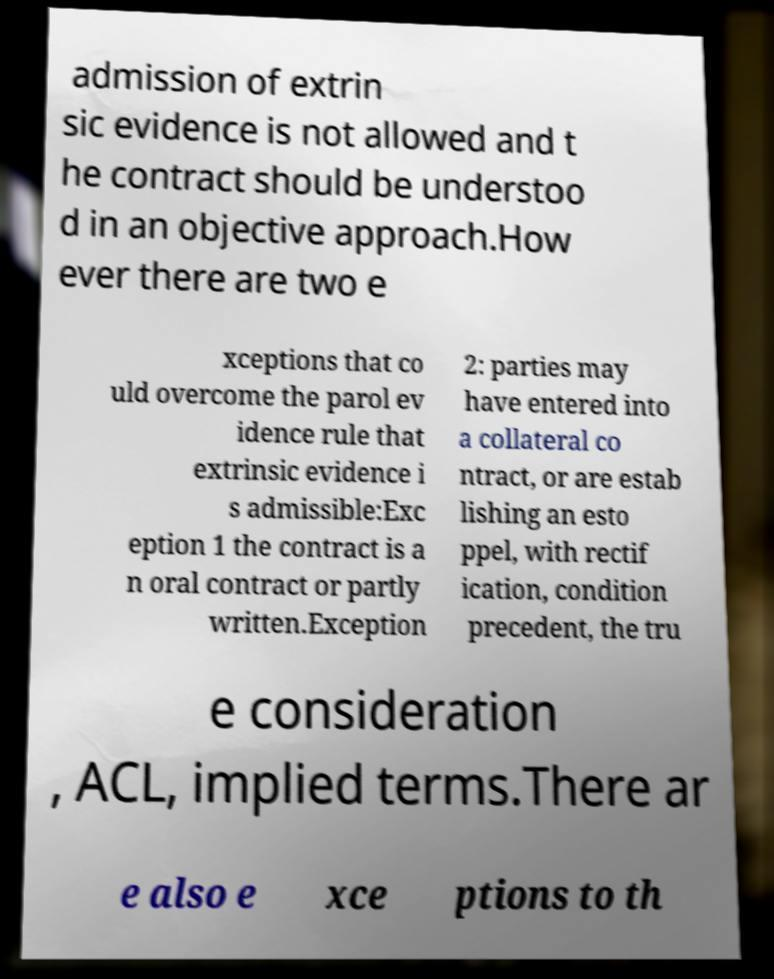Can you read and provide the text displayed in the image?This photo seems to have some interesting text. Can you extract and type it out for me? admission of extrin sic evidence is not allowed and t he contract should be understoo d in an objective approach.How ever there are two e xceptions that co uld overcome the parol ev idence rule that extrinsic evidence i s admissible:Exc eption 1 the contract is a n oral contract or partly written.Exception 2: parties may have entered into a collateral co ntract, or are estab lishing an esto ppel, with rectif ication, condition precedent, the tru e consideration , ACL, implied terms.There ar e also e xce ptions to th 